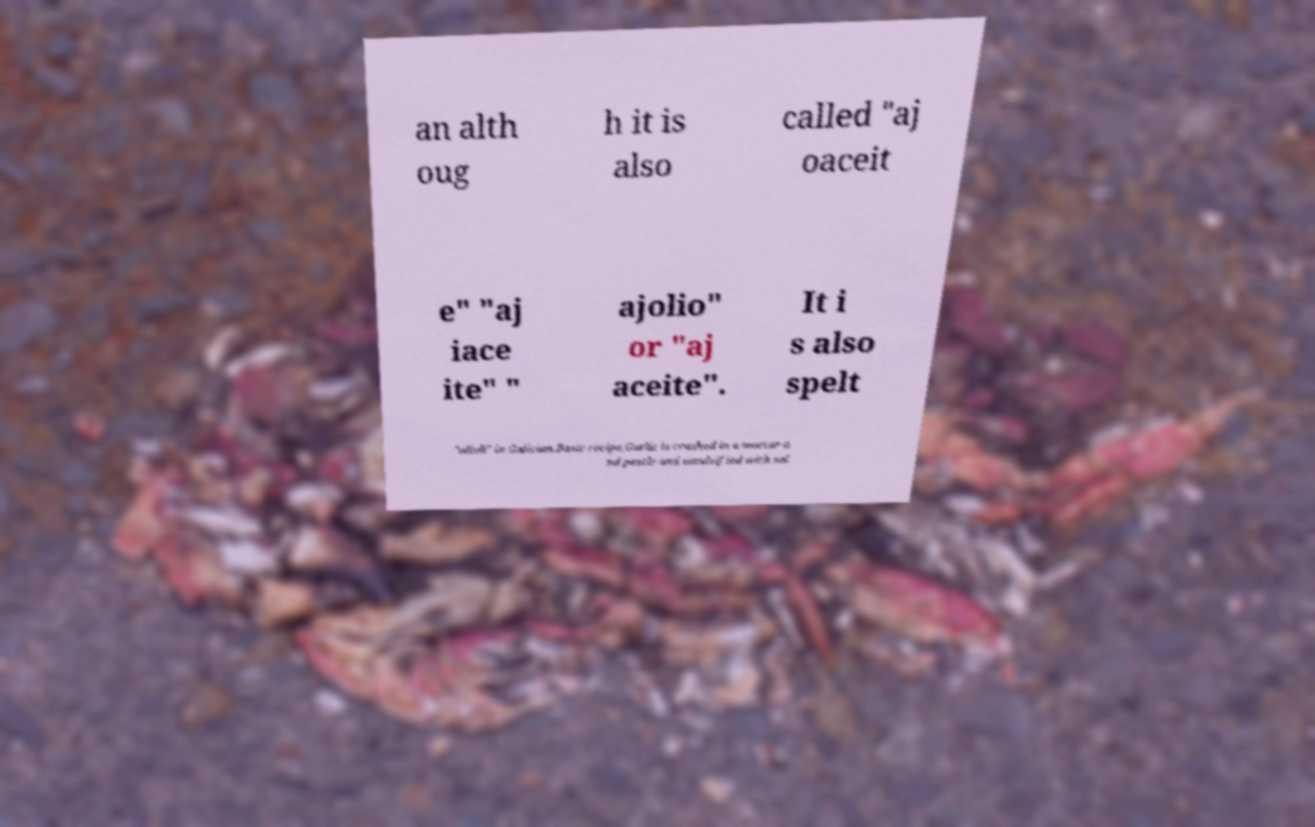I need the written content from this picture converted into text. Can you do that? an alth oug h it is also called "aj oaceit e" "aj iace ite" " ajolio" or "aj aceite". It i s also spelt "alioli" in Galician.Basic recipe.Garlic is crushed in a mortar a nd pestle and emulsified with sal 